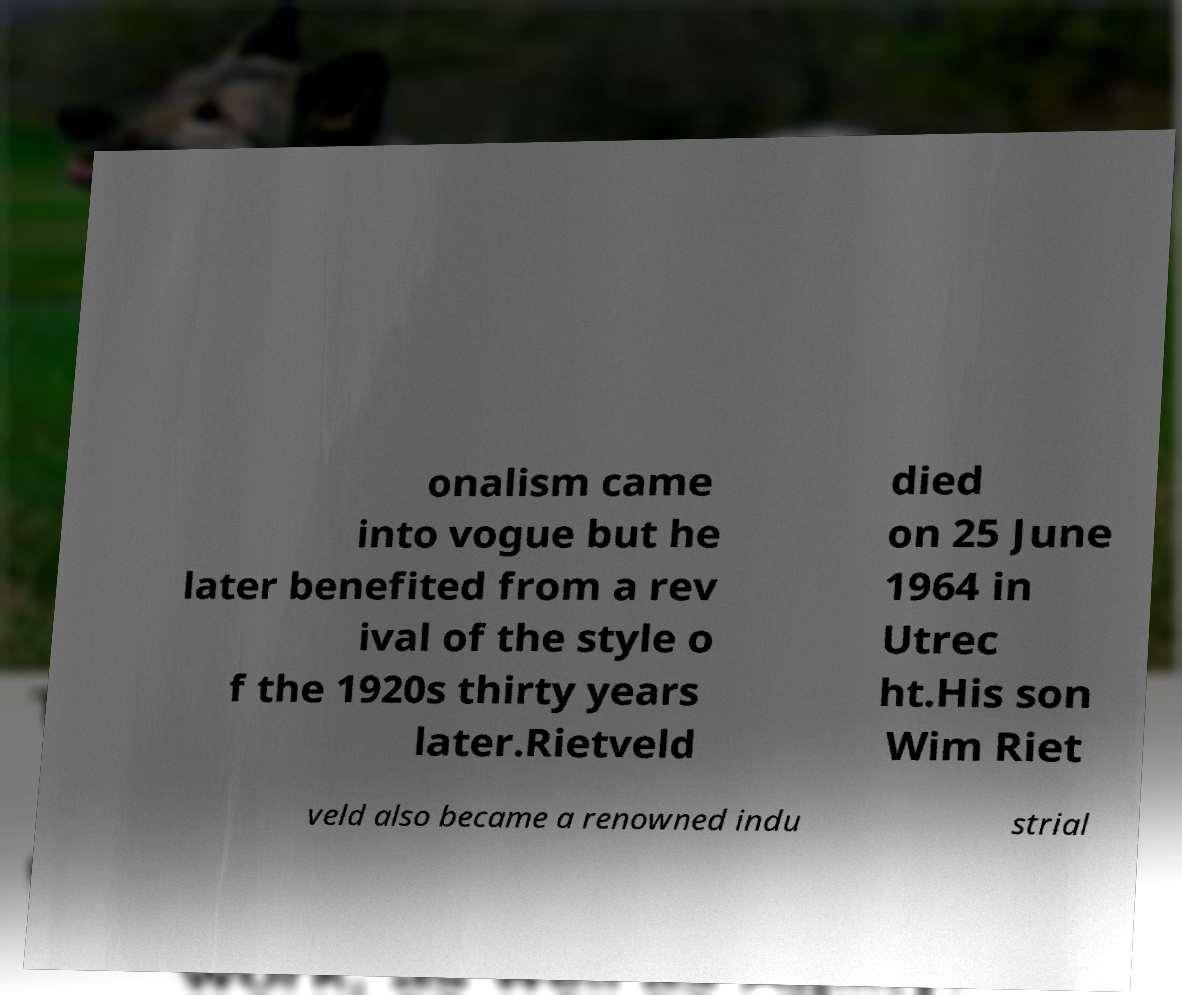There's text embedded in this image that I need extracted. Can you transcribe it verbatim? onalism came into vogue but he later benefited from a rev ival of the style o f the 1920s thirty years later.Rietveld died on 25 June 1964 in Utrec ht.His son Wim Riet veld also became a renowned indu strial 